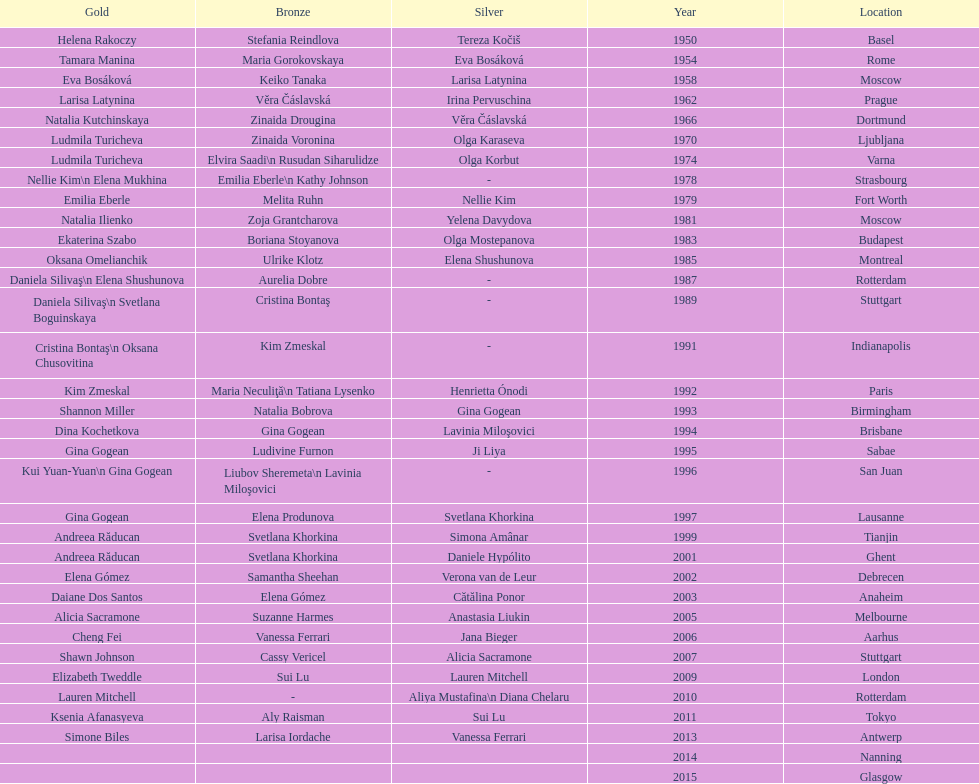How many times was the location in the united states? 3. 